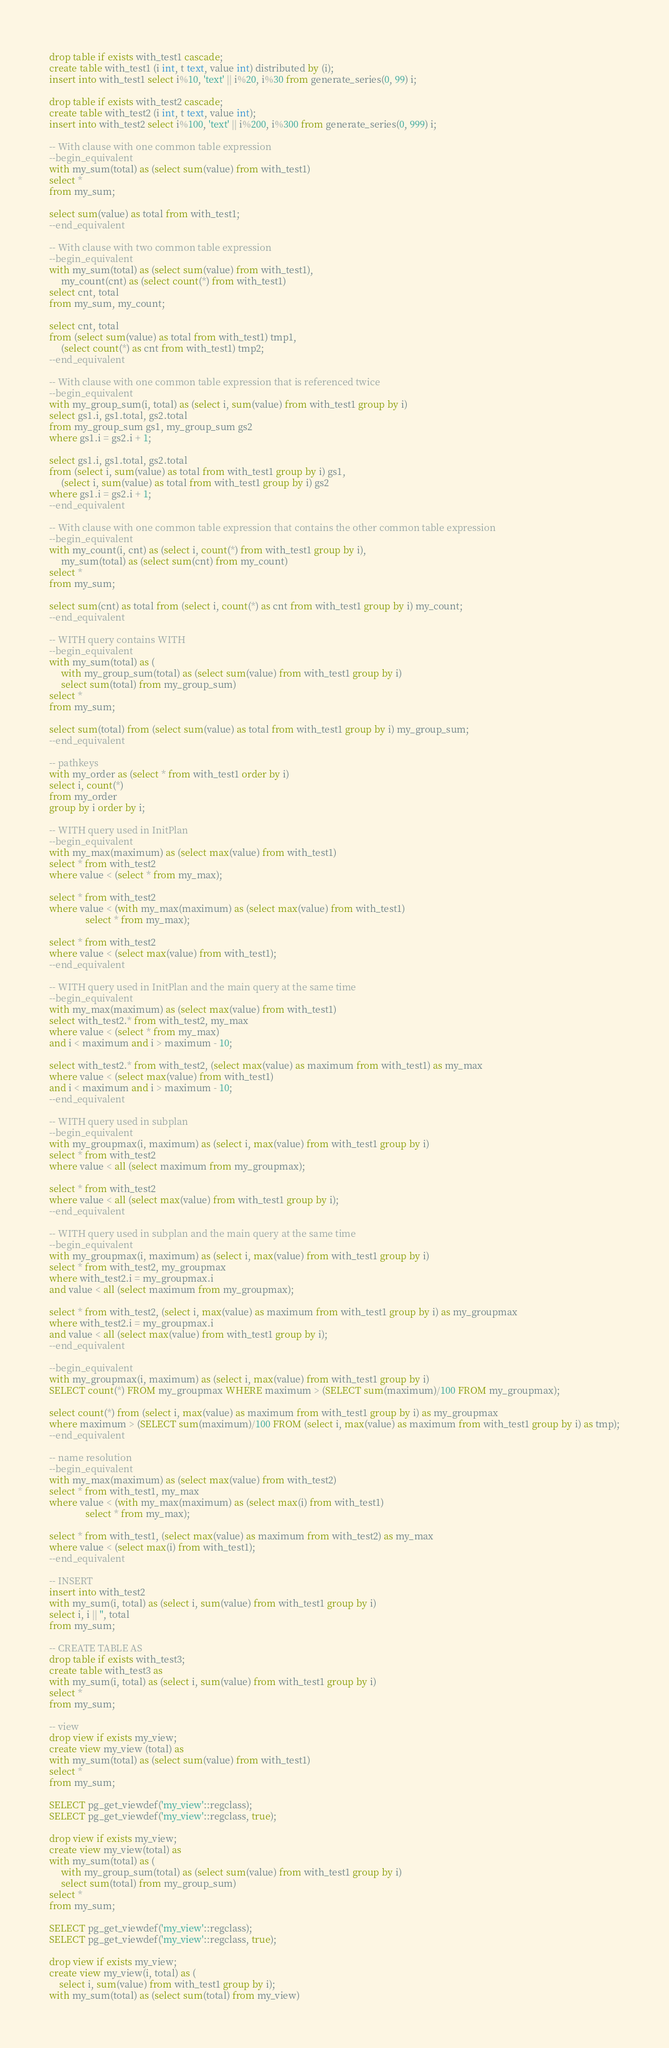<code> <loc_0><loc_0><loc_500><loc_500><_SQL_>drop table if exists with_test1 cascade;
create table with_test1 (i int, t text, value int) distributed by (i);
insert into with_test1 select i%10, 'text' || i%20, i%30 from generate_series(0, 99) i;

drop table if exists with_test2 cascade;
create table with_test2 (i int, t text, value int);
insert into with_test2 select i%100, 'text' || i%200, i%300 from generate_series(0, 999) i;

-- With clause with one common table expression
--begin_equivalent
with my_sum(total) as (select sum(value) from with_test1)
select *
from my_sum;

select sum(value) as total from with_test1;
--end_equivalent

-- With clause with two common table expression
--begin_equivalent
with my_sum(total) as (select sum(value) from with_test1),
     my_count(cnt) as (select count(*) from with_test1)
select cnt, total
from my_sum, my_count;

select cnt, total
from (select sum(value) as total from with_test1) tmp1,
     (select count(*) as cnt from with_test1) tmp2;
--end_equivalent

-- With clause with one common table expression that is referenced twice
--begin_equivalent
with my_group_sum(i, total) as (select i, sum(value) from with_test1 group by i)
select gs1.i, gs1.total, gs2.total
from my_group_sum gs1, my_group_sum gs2
where gs1.i = gs2.i + 1;

select gs1.i, gs1.total, gs2.total
from (select i, sum(value) as total from with_test1 group by i) gs1,
     (select i, sum(value) as total from with_test1 group by i) gs2
where gs1.i = gs2.i + 1;
--end_equivalent

-- With clause with one common table expression that contains the other common table expression
--begin_equivalent
with my_count(i, cnt) as (select i, count(*) from with_test1 group by i),
     my_sum(total) as (select sum(cnt) from my_count)
select *
from my_sum;

select sum(cnt) as total from (select i, count(*) as cnt from with_test1 group by i) my_count;
--end_equivalent

-- WITH query contains WITH
--begin_equivalent
with my_sum(total) as (
     with my_group_sum(total) as (select sum(value) from with_test1 group by i)
     select sum(total) from my_group_sum)
select *
from my_sum;

select sum(total) from (select sum(value) as total from with_test1 group by i) my_group_sum;
--end_equivalent

-- pathkeys
with my_order as (select * from with_test1 order by i)
select i, count(*)
from my_order
group by i order by i;

-- WITH query used in InitPlan
--begin_equivalent
with my_max(maximum) as (select max(value) from with_test1)
select * from with_test2
where value < (select * from my_max);

select * from with_test2
where value < (with my_max(maximum) as (select max(value) from with_test1)
               select * from my_max);

select * from with_test2
where value < (select max(value) from with_test1);
--end_equivalent

-- WITH query used in InitPlan and the main query at the same time
--begin_equivalent
with my_max(maximum) as (select max(value) from with_test1)
select with_test2.* from with_test2, my_max
where value < (select * from my_max)
and i < maximum and i > maximum - 10;

select with_test2.* from with_test2, (select max(value) as maximum from with_test1) as my_max
where value < (select max(value) from with_test1)
and i < maximum and i > maximum - 10;
--end_equivalent

-- WITH query used in subplan
--begin_equivalent
with my_groupmax(i, maximum) as (select i, max(value) from with_test1 group by i)
select * from with_test2
where value < all (select maximum from my_groupmax);

select * from with_test2
where value < all (select max(value) from with_test1 group by i);
--end_equivalent

-- WITH query used in subplan and the main query at the same time
--begin_equivalent
with my_groupmax(i, maximum) as (select i, max(value) from with_test1 group by i)
select * from with_test2, my_groupmax
where with_test2.i = my_groupmax.i
and value < all (select maximum from my_groupmax);

select * from with_test2, (select i, max(value) as maximum from with_test1 group by i) as my_groupmax
where with_test2.i = my_groupmax.i
and value < all (select max(value) from with_test1 group by i);
--end_equivalent

--begin_equivalent
with my_groupmax(i, maximum) as (select i, max(value) from with_test1 group by i)
SELECT count(*) FROM my_groupmax WHERE maximum > (SELECT sum(maximum)/100 FROM my_groupmax);

select count(*) from (select i, max(value) as maximum from with_test1 group by i) as my_groupmax
where maximum > (SELECT sum(maximum)/100 FROM (select i, max(value) as maximum from with_test1 group by i) as tmp);
--end_equivalent

-- name resolution
--begin_equivalent
with my_max(maximum) as (select max(value) from with_test2)
select * from with_test1, my_max
where value < (with my_max(maximum) as (select max(i) from with_test1)
               select * from my_max);

select * from with_test1, (select max(value) as maximum from with_test2) as my_max
where value < (select max(i) from with_test1);
--end_equivalent

-- INSERT
insert into with_test2
with my_sum(i, total) as (select i, sum(value) from with_test1 group by i)
select i, i || '', total
from my_sum;

-- CREATE TABLE AS
drop table if exists with_test3;
create table with_test3 as
with my_sum(i, total) as (select i, sum(value) from with_test1 group by i)
select *
from my_sum;

-- view
drop view if exists my_view;
create view my_view (total) as
with my_sum(total) as (select sum(value) from with_test1)
select *
from my_sum;

SELECT pg_get_viewdef('my_view'::regclass);
SELECT pg_get_viewdef('my_view'::regclass, true);

drop view if exists my_view;
create view my_view(total) as
with my_sum(total) as (
     with my_group_sum(total) as (select sum(value) from with_test1 group by i)
     select sum(total) from my_group_sum)
select *
from my_sum;

SELECT pg_get_viewdef('my_view'::regclass);
SELECT pg_get_viewdef('my_view'::regclass, true);

drop view if exists my_view;
create view my_view(i, total) as (
    select i, sum(value) from with_test1 group by i);
with my_sum(total) as (select sum(total) from my_view)</code> 